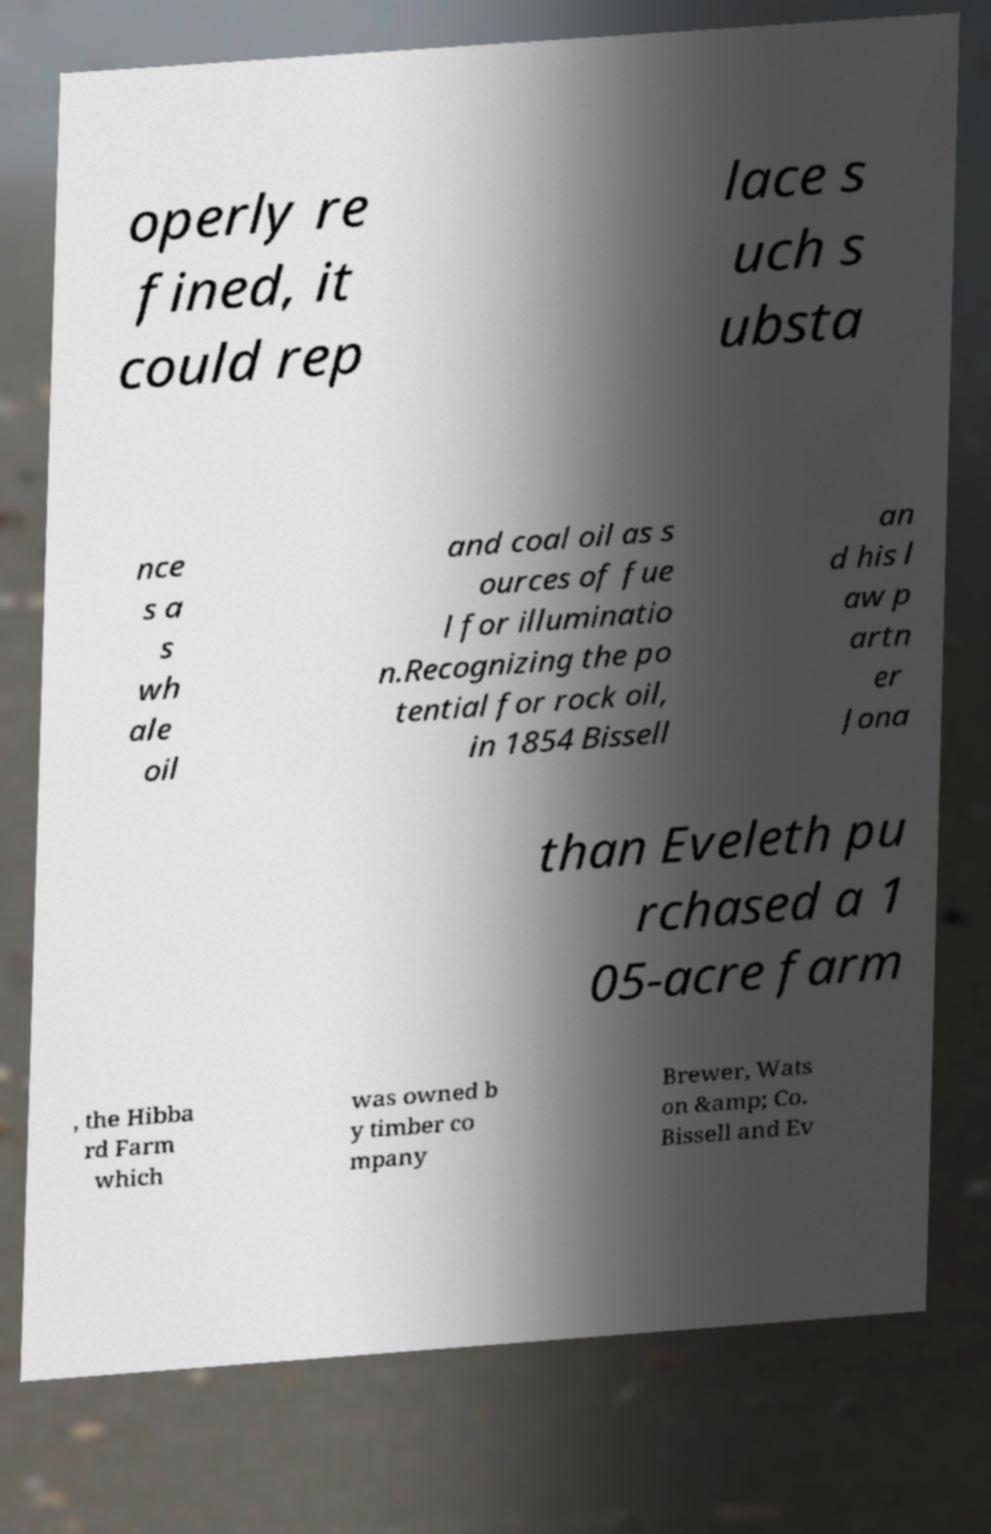Could you extract and type out the text from this image? operly re fined, it could rep lace s uch s ubsta nce s a s wh ale oil and coal oil as s ources of fue l for illuminatio n.Recognizing the po tential for rock oil, in 1854 Bissell an d his l aw p artn er Jona than Eveleth pu rchased a 1 05-acre farm , the Hibba rd Farm which was owned b y timber co mpany Brewer, Wats on &amp; Co. Bissell and Ev 